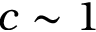Convert formula to latex. <formula><loc_0><loc_0><loc_500><loc_500>c \sim 1</formula> 